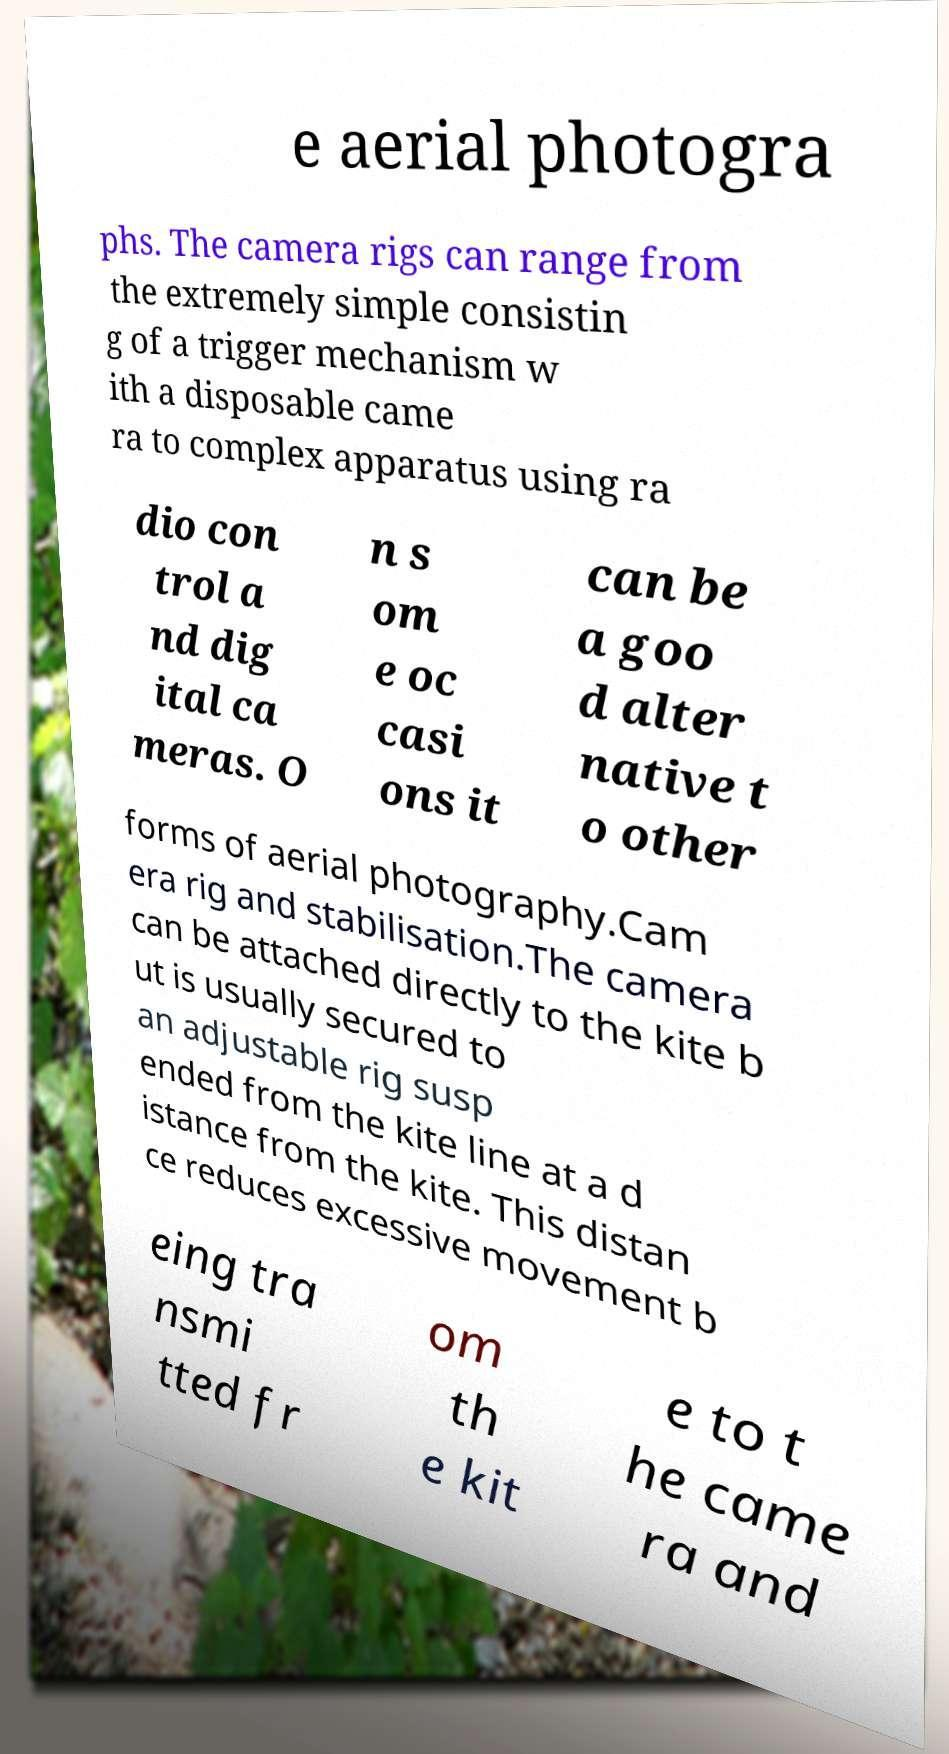I need the written content from this picture converted into text. Can you do that? e aerial photogra phs. The camera rigs can range from the extremely simple consistin g of a trigger mechanism w ith a disposable came ra to complex apparatus using ra dio con trol a nd dig ital ca meras. O n s om e oc casi ons it can be a goo d alter native t o other forms of aerial photography.Cam era rig and stabilisation.The camera can be attached directly to the kite b ut is usually secured to an adjustable rig susp ended from the kite line at a d istance from the kite. This distan ce reduces excessive movement b eing tra nsmi tted fr om th e kit e to t he came ra and 